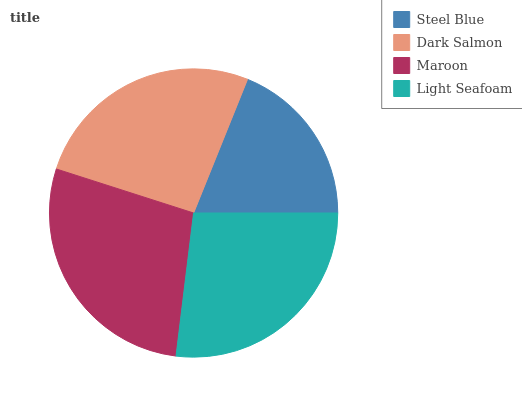Is Steel Blue the minimum?
Answer yes or no. Yes. Is Maroon the maximum?
Answer yes or no. Yes. Is Dark Salmon the minimum?
Answer yes or no. No. Is Dark Salmon the maximum?
Answer yes or no. No. Is Dark Salmon greater than Steel Blue?
Answer yes or no. Yes. Is Steel Blue less than Dark Salmon?
Answer yes or no. Yes. Is Steel Blue greater than Dark Salmon?
Answer yes or no. No. Is Dark Salmon less than Steel Blue?
Answer yes or no. No. Is Light Seafoam the high median?
Answer yes or no. Yes. Is Dark Salmon the low median?
Answer yes or no. Yes. Is Maroon the high median?
Answer yes or no. No. Is Maroon the low median?
Answer yes or no. No. 